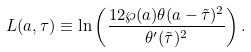Convert formula to latex. <formula><loc_0><loc_0><loc_500><loc_500>L ( a , \tau ) \equiv \ln \left ( \frac { 1 2 \wp ( a ) \theta ( a - \tilde { \tau } ) ^ { 2 } } { \theta ^ { \prime } ( \tilde { \tau } ) ^ { 2 } } \right ) .</formula> 